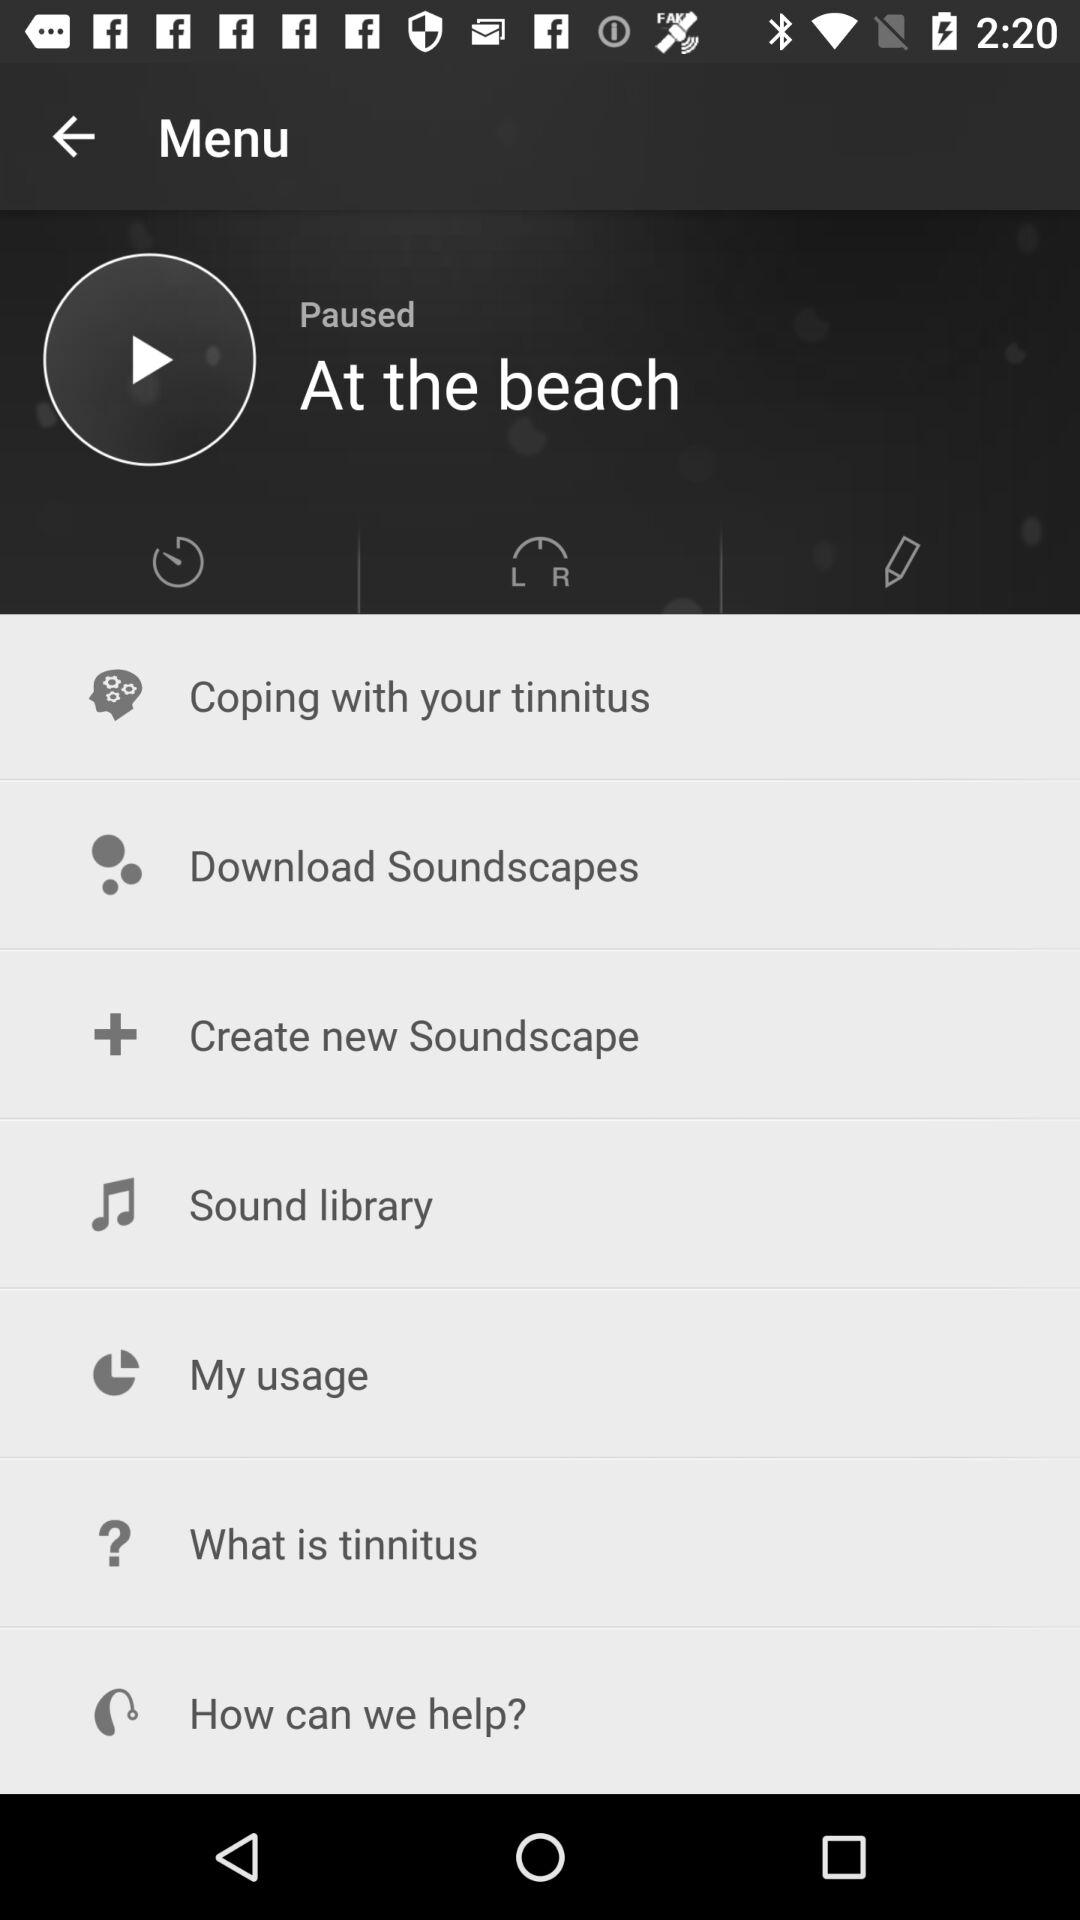What is the name of the music that is paused? The name of the music is "At the beach". 